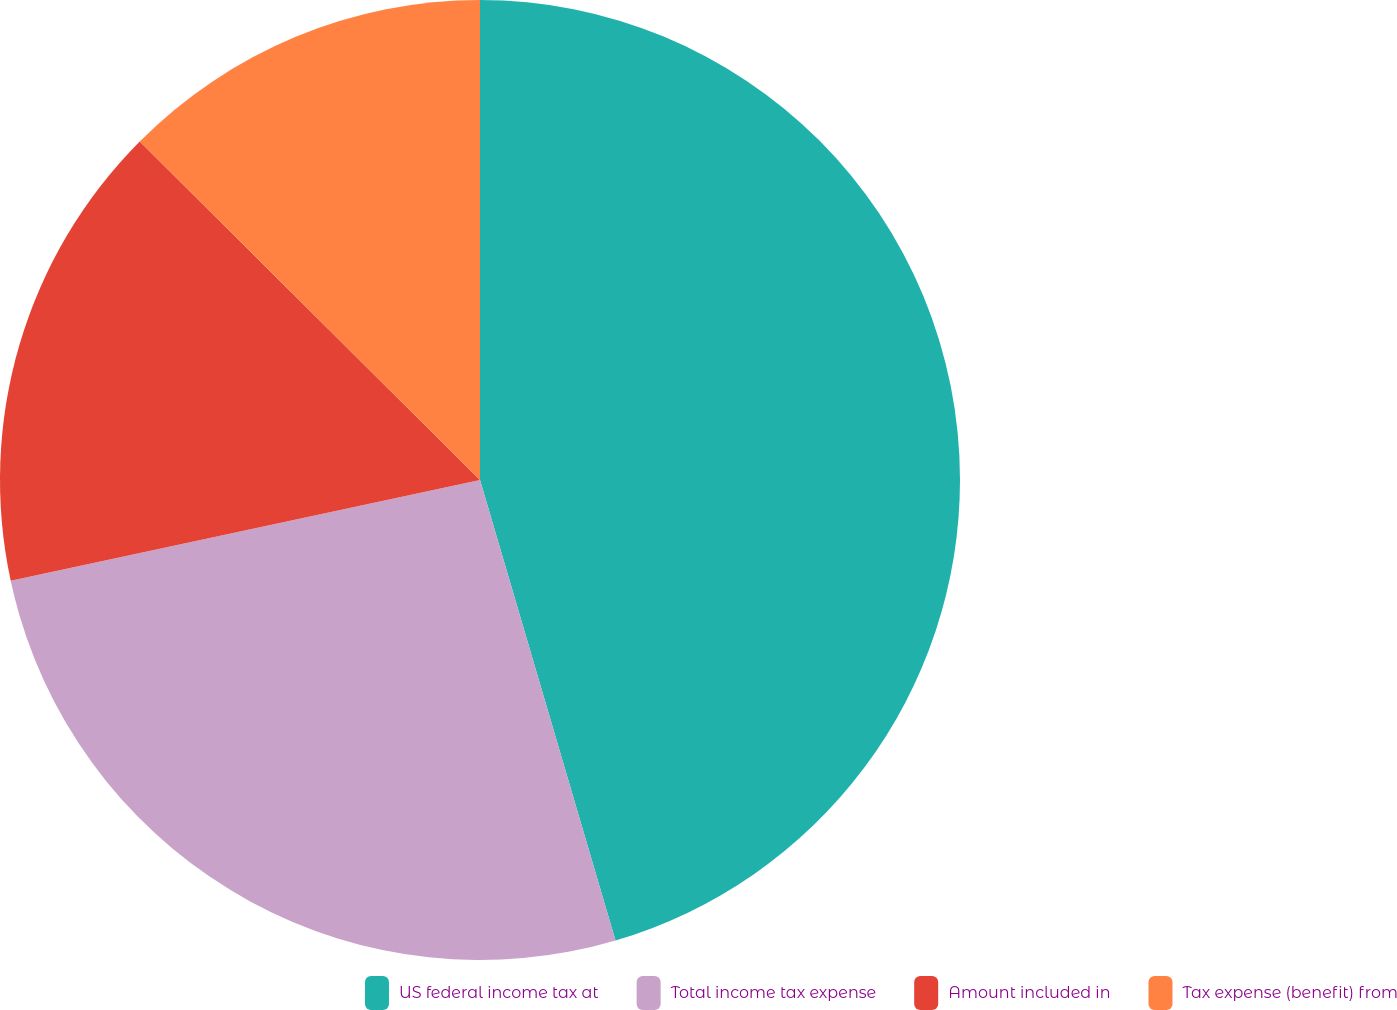<chart> <loc_0><loc_0><loc_500><loc_500><pie_chart><fcel>US federal income tax at<fcel>Total income tax expense<fcel>Amount included in<fcel>Tax expense (benefit) from<nl><fcel>45.45%<fcel>26.19%<fcel>15.83%<fcel>12.54%<nl></chart> 